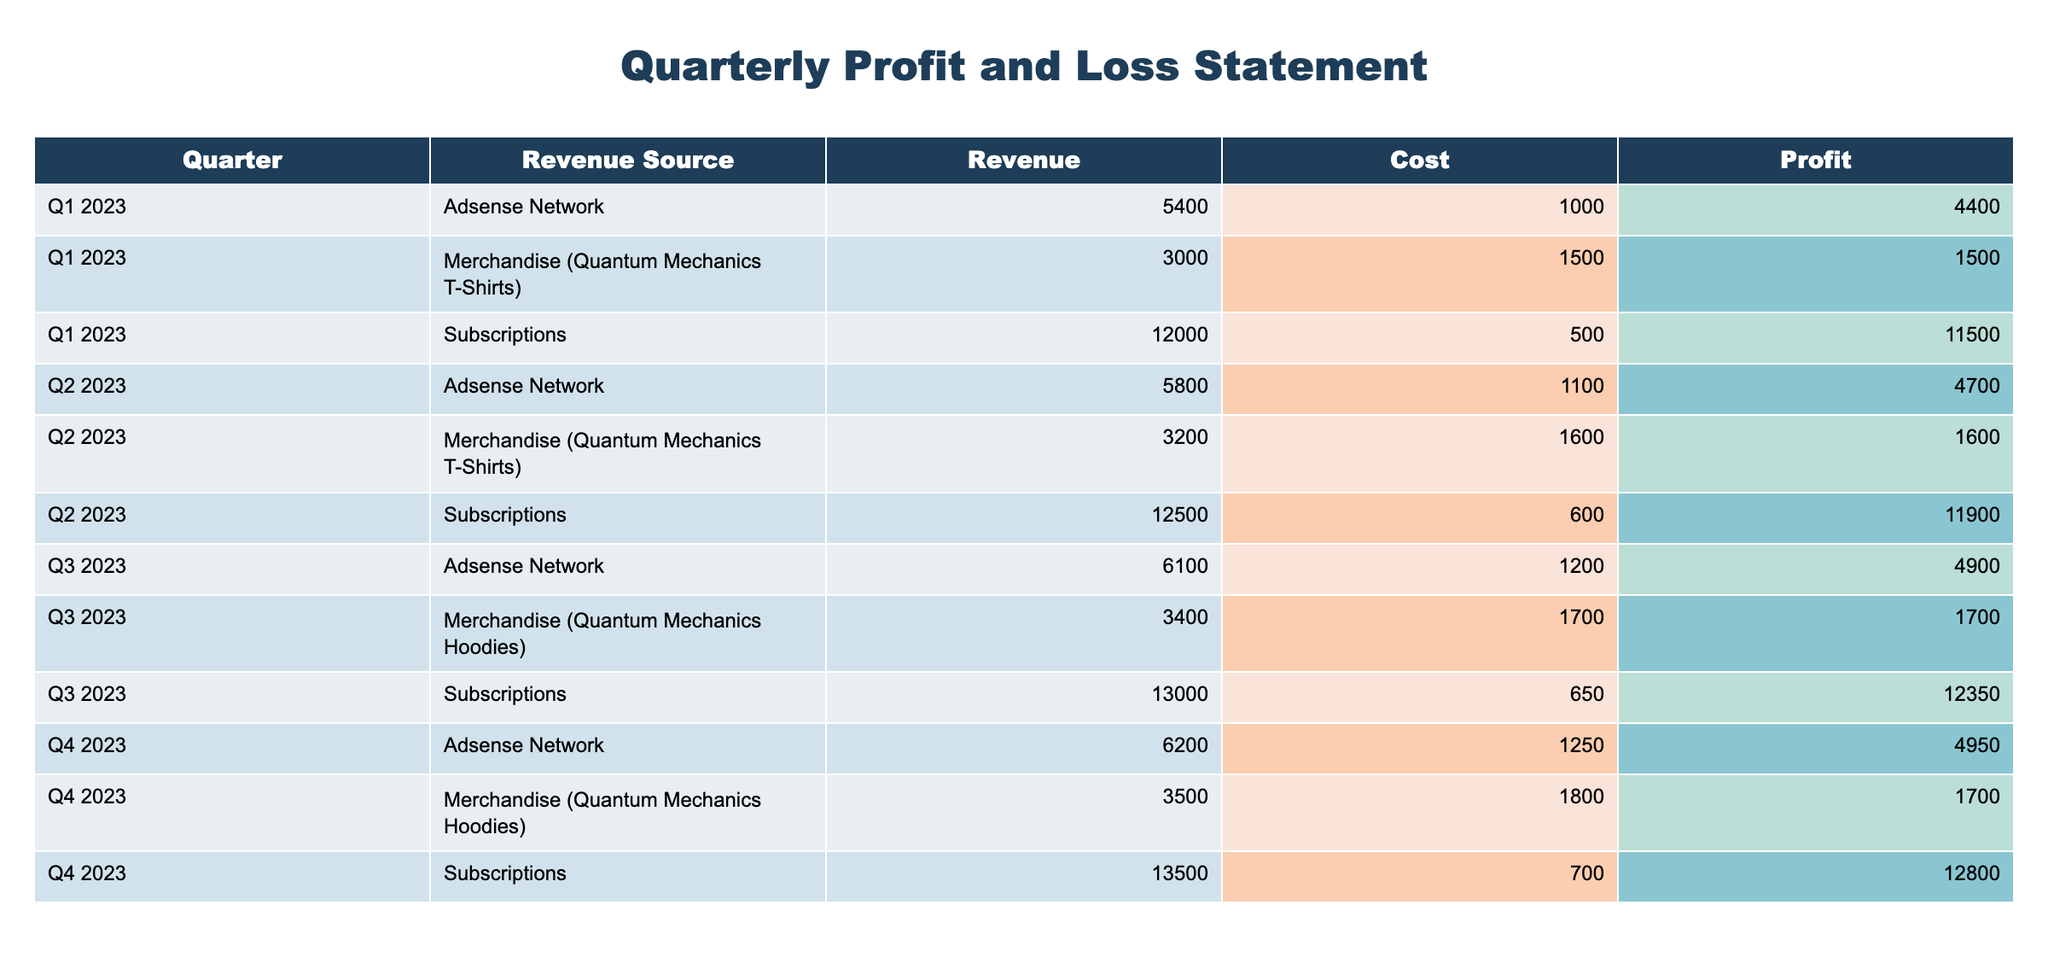What is the total profit from subscriptions in Q4 2023? The profit from subscriptions in Q4 2023 is listed directly in the table as 12800.
Answer: 12800 What was the revenue from merchandise in Q3 2023? The revenue from merchandise in Q3 2023, represented as "Quantum Mechanics Hoodies," is displayed in the table as 3400.
Answer: 3400 Was the profit from ads in Q2 2023 higher than in Q1 2023? The profit from ads in Q2 2023 is 4700, while in Q1 2023 it is 4400. Since 4700 is greater than 4400, the statement is true.
Answer: Yes What is the average profit across all revenue sources for Q1 2023? The profits for Q1 2023 are 4400 (Adsense), 11500 (Subscriptions), and 1500 (Merchandise), leading to a total profit of 4400 + 11500 + 1500 = 17400. The average profit is then 17400 / 3 = 5800.
Answer: 5800 Which quarter had the highest total revenue and what was that revenue? To find the total revenue for each quarter, we sum the revenue from all sources in each quarter: Q1 2023 = 5400 + 12000 + 3000 = 20400, Q2 2023 = 5800 + 12500 + 3200 = 21100, Q3 2023 = 6100 + 13000 + 3400 = 22500, Q4 2023 = 6200 + 13500 + 3500 = 23200. Since 23200 is the greatest, Q4 2023 had the highest total revenue.
Answer: Q4 2023, 23200 How much did merchandise cost in Q2 2023 compared to Q3 2023? The cost of merchandise in Q2 2023 is 1600 and in Q3 2023 it is 1700. Comparing these values shows that 1600 is less than 1700, thus the cost in Q2 is lower than in Q3.
Answer: Lower 